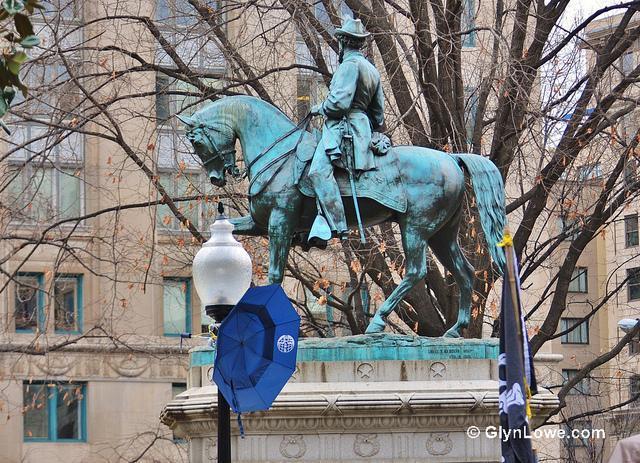How many people are sitting on the bench?
Give a very brief answer. 0. 